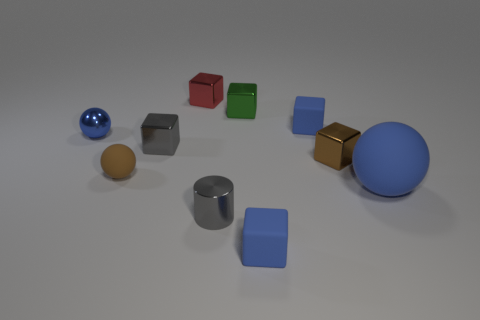What number of things are either large shiny things or small shiny objects that are in front of the small green metal object?
Your answer should be very brief. 4. Is the number of brown metallic cubes behind the blue metallic ball less than the number of metal cubes behind the tiny red metal thing?
Give a very brief answer. No. What number of other objects are there of the same material as the small gray block?
Your answer should be very brief. 5. Do the matte cube that is in front of the small blue metal thing and the metallic cylinder have the same color?
Provide a succinct answer. No. There is a blue cube that is in front of the blue metallic object; are there any shiny balls that are to the right of it?
Your answer should be compact. No. There is a blue thing that is in front of the brown metal thing and left of the small brown metal object; what material is it?
Provide a short and direct response. Rubber. What shape is the red object that is the same material as the green cube?
Provide a succinct answer. Cube. Are there any other things that have the same shape as the large thing?
Your response must be concise. Yes. Are the small cube that is in front of the big matte object and the tiny green object made of the same material?
Your answer should be very brief. No. What material is the blue sphere to the right of the brown cube?
Offer a very short reply. Rubber. 